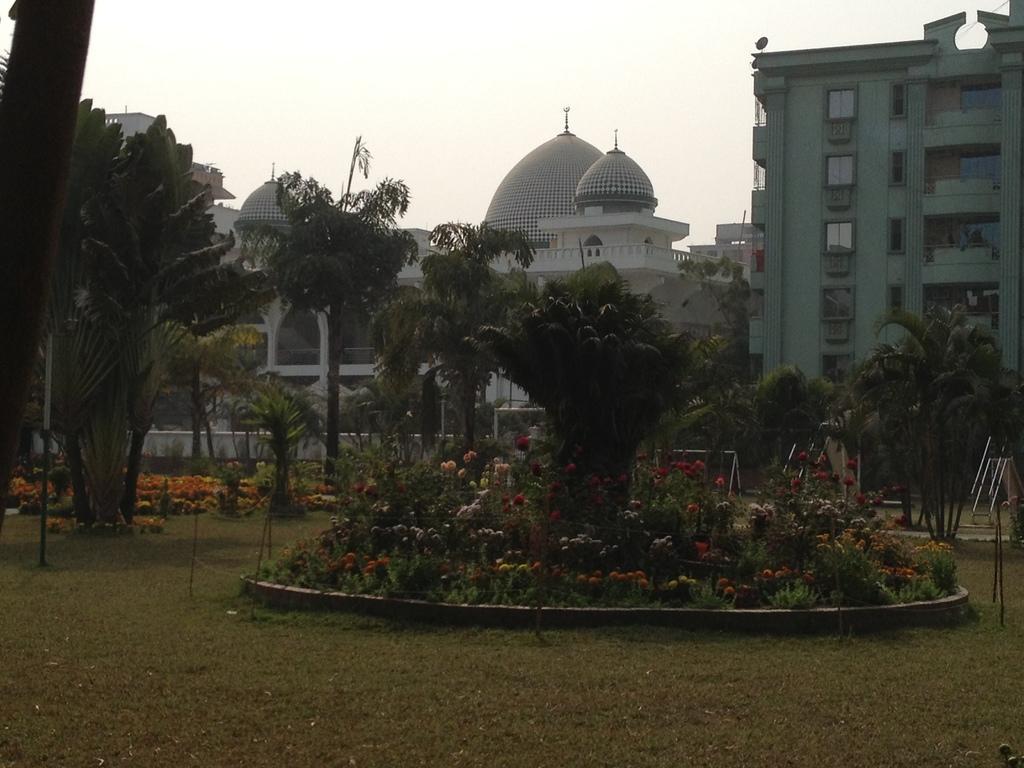Please provide a concise description of this image. In this image we can see some buildings with windows and pillars. We can also see a group of trees, grass, poles, some plants with flowers and the sky which looks cloudy. 